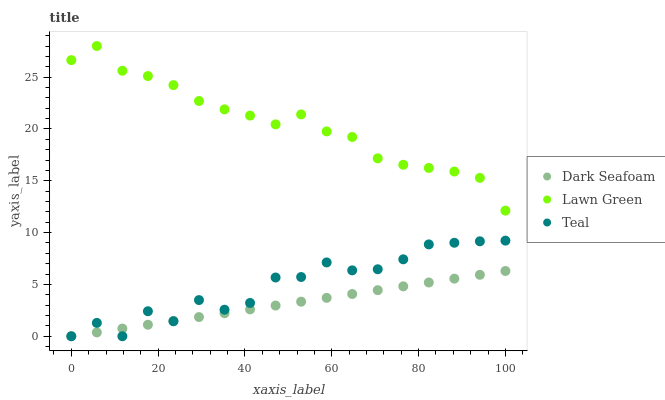Does Dark Seafoam have the minimum area under the curve?
Answer yes or no. Yes. Does Lawn Green have the maximum area under the curve?
Answer yes or no. Yes. Does Teal have the minimum area under the curve?
Answer yes or no. No. Does Teal have the maximum area under the curve?
Answer yes or no. No. Is Dark Seafoam the smoothest?
Answer yes or no. Yes. Is Teal the roughest?
Answer yes or no. Yes. Is Teal the smoothest?
Answer yes or no. No. Is Dark Seafoam the roughest?
Answer yes or no. No. Does Dark Seafoam have the lowest value?
Answer yes or no. Yes. Does Lawn Green have the highest value?
Answer yes or no. Yes. Does Teal have the highest value?
Answer yes or no. No. Is Dark Seafoam less than Lawn Green?
Answer yes or no. Yes. Is Lawn Green greater than Teal?
Answer yes or no. Yes. Does Teal intersect Dark Seafoam?
Answer yes or no. Yes. Is Teal less than Dark Seafoam?
Answer yes or no. No. Is Teal greater than Dark Seafoam?
Answer yes or no. No. Does Dark Seafoam intersect Lawn Green?
Answer yes or no. No. 